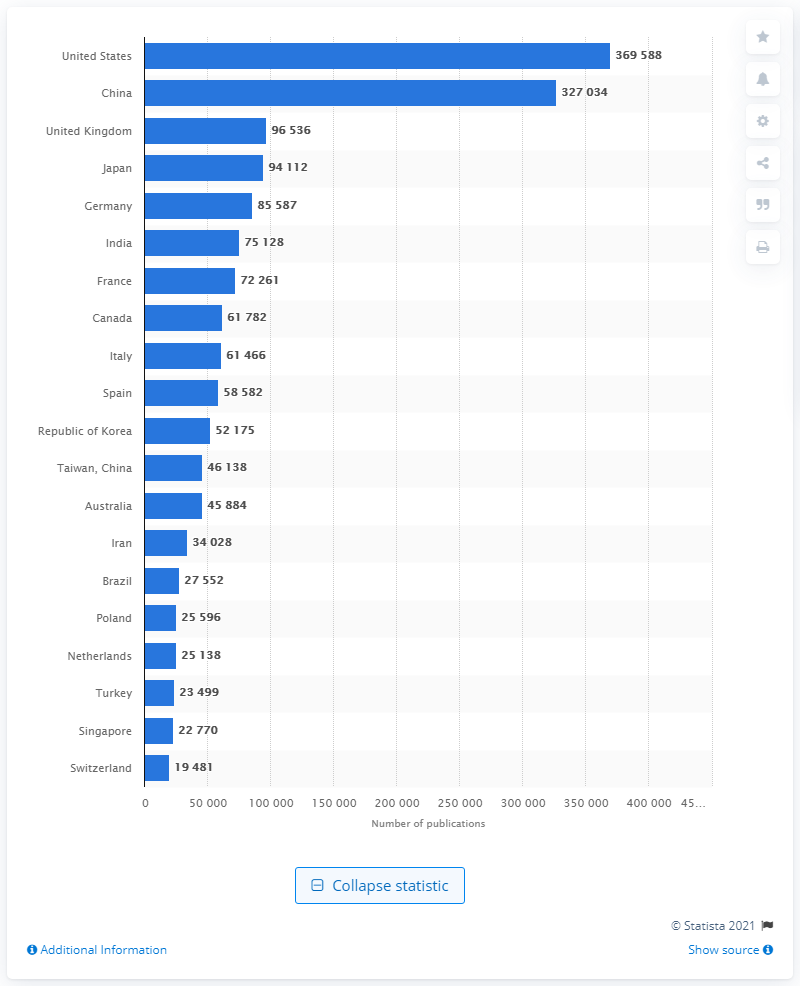Indicate a few pertinent items in this graphic. During the period of 1997 to 2017, a total of 369,588 AI-related papers were published in the United States. 